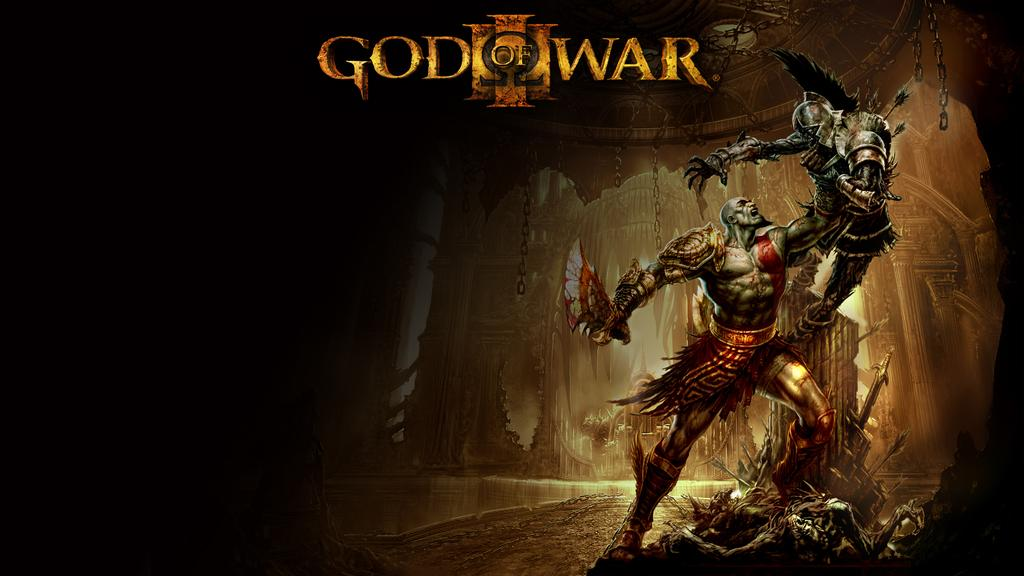<image>
Describe the image concisely. A poster from the God of War action movie 